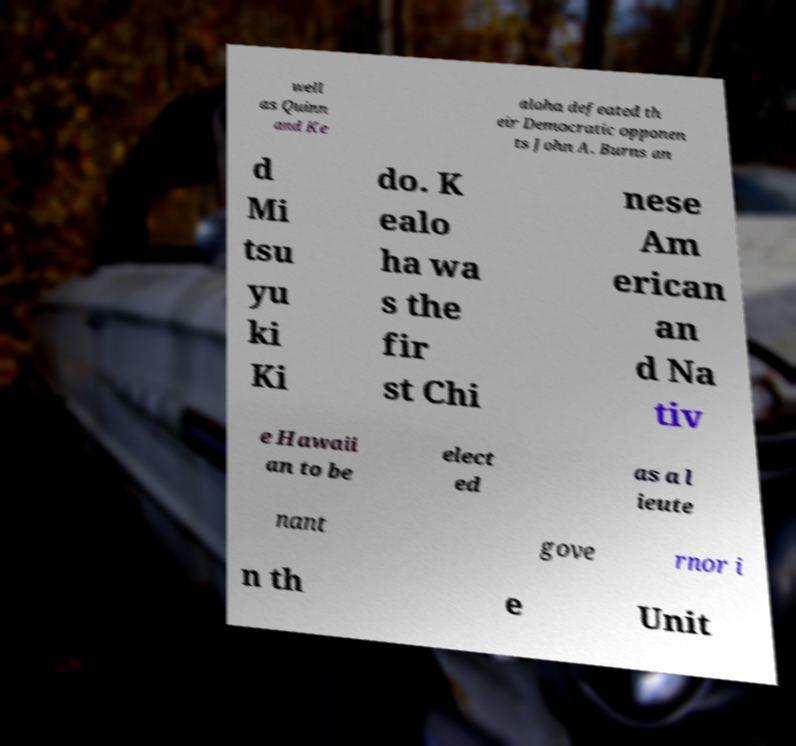Please read and relay the text visible in this image. What does it say? well as Quinn and Ke aloha defeated th eir Democratic opponen ts John A. Burns an d Mi tsu yu ki Ki do. K ealo ha wa s the fir st Chi nese Am erican an d Na tiv e Hawaii an to be elect ed as a l ieute nant gove rnor i n th e Unit 